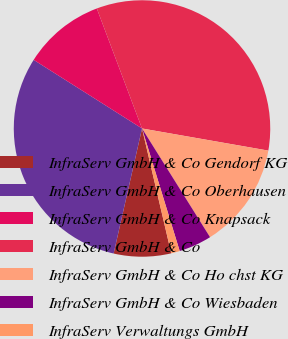<chart> <loc_0><loc_0><loc_500><loc_500><pie_chart><fcel>InfraServ GmbH & Co Gendorf KG<fcel>InfraServ GmbH & Co Oberhausen<fcel>InfraServ GmbH & Co Knapsack<fcel>InfraServ GmbH & Co<fcel>InfraServ GmbH & Co Ho chst KG<fcel>InfraServ GmbH & Co Wiesbaden<fcel>InfraServ Verwaltungs GmbH<nl><fcel>7.21%<fcel>30.43%<fcel>10.28%<fcel>33.49%<fcel>13.34%<fcel>4.15%<fcel>1.09%<nl></chart> 